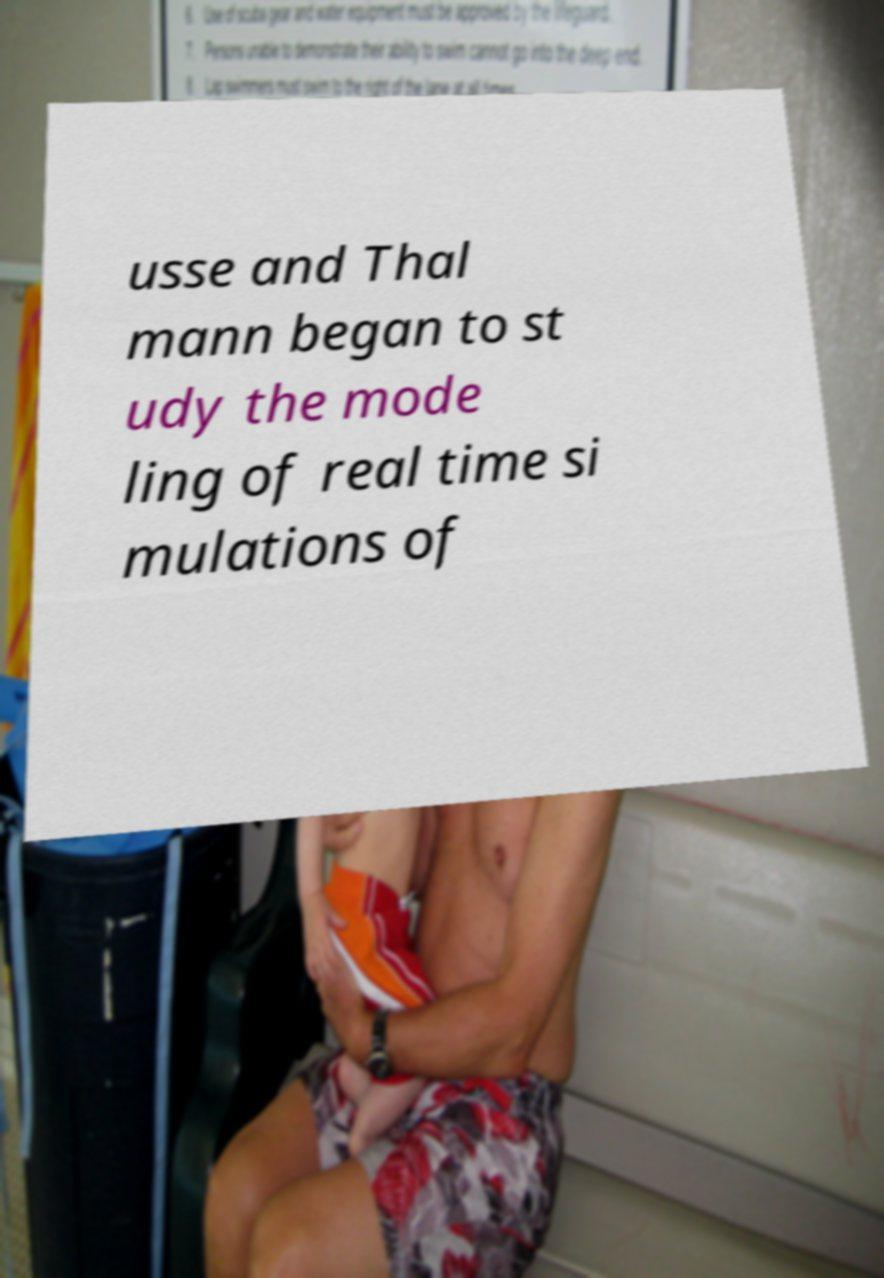I need the written content from this picture converted into text. Can you do that? usse and Thal mann began to st udy the mode ling of real time si mulations of 